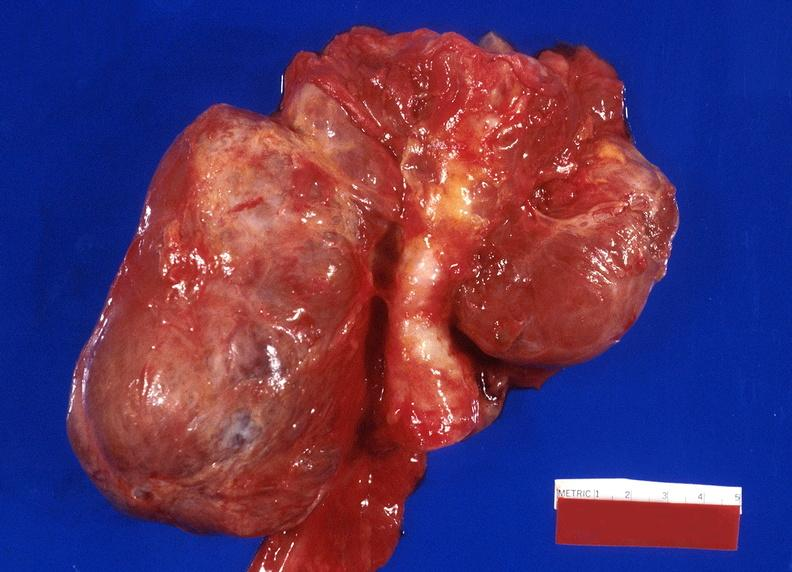what does this image show?
Answer the question using a single word or phrase. Thyroid 